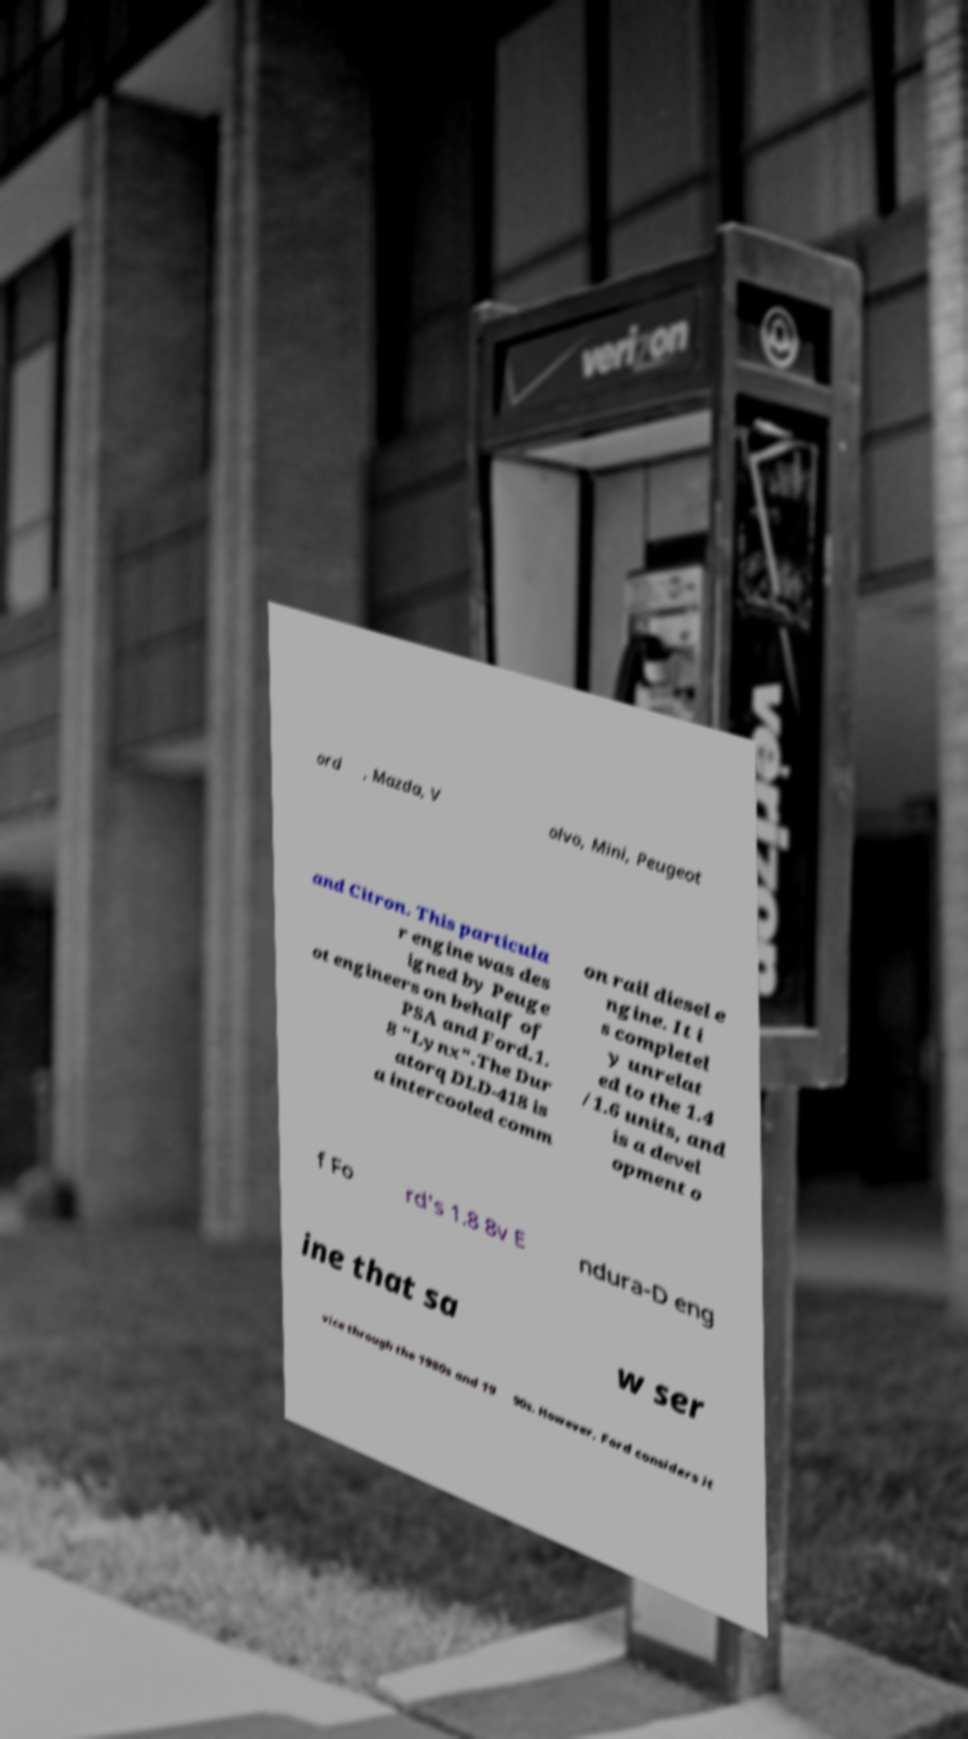Please read and relay the text visible in this image. What does it say? ord , Mazda, V olvo, Mini, Peugeot and Citron. This particula r engine was des igned by Peuge ot engineers on behalf of PSA and Ford.1. 8 "Lynx".The Dur atorq DLD-418 is a intercooled comm on rail diesel e ngine. It i s completel y unrelat ed to the 1.4 /1.6 units, and is a devel opment o f Fo rd's 1.8 8v E ndura-D eng ine that sa w ser vice through the 1980s and 19 90s. However, Ford considers it 